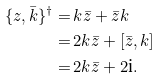Convert formula to latex. <formula><loc_0><loc_0><loc_500><loc_500>\{ z , \bar { k } \} ^ { \dag } = & \, k \bar { z } + \bar { z } k \\ = & \, 2 k \bar { z } + [ \bar { z } , k ] \\ = & \, 2 k \bar { z } + 2 \text {i} .</formula> 